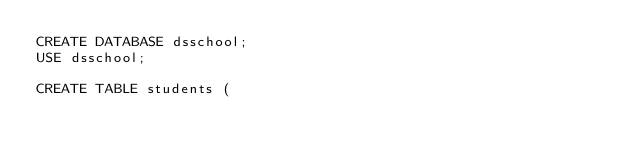Convert code to text. <code><loc_0><loc_0><loc_500><loc_500><_SQL_>CREATE DATABASE dsschool;
USE dsschool;

CREATE TABLE students (</code> 